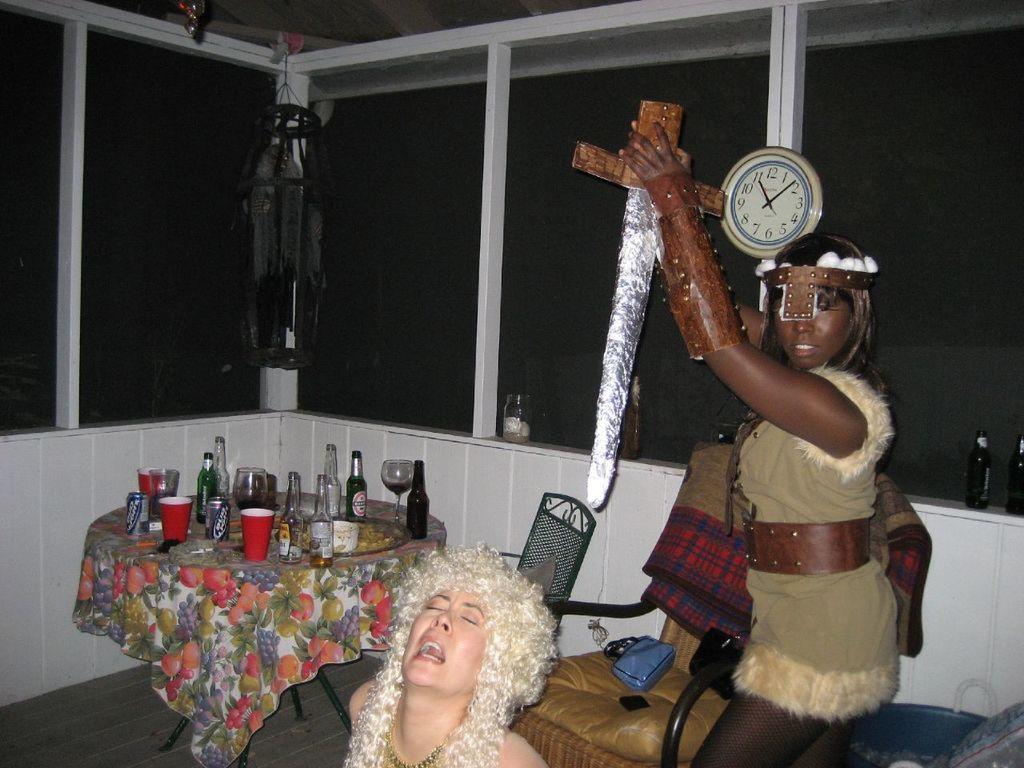In one or two sentences, can you explain what this image depicts? In this image there is a woman standing, he is holding an object, there is a woman towards the bottom of the image, there are chairs, there is an object on the chair, there is a table, there is a cloth on the table, there are objects on the cloth, there is a wall clock, there are objects towards the right of the image, there are glass windows, there is a wall, there is an object hanging, there is an object towards the top of the image, there is a wooden floor towards the bottom of the image. 